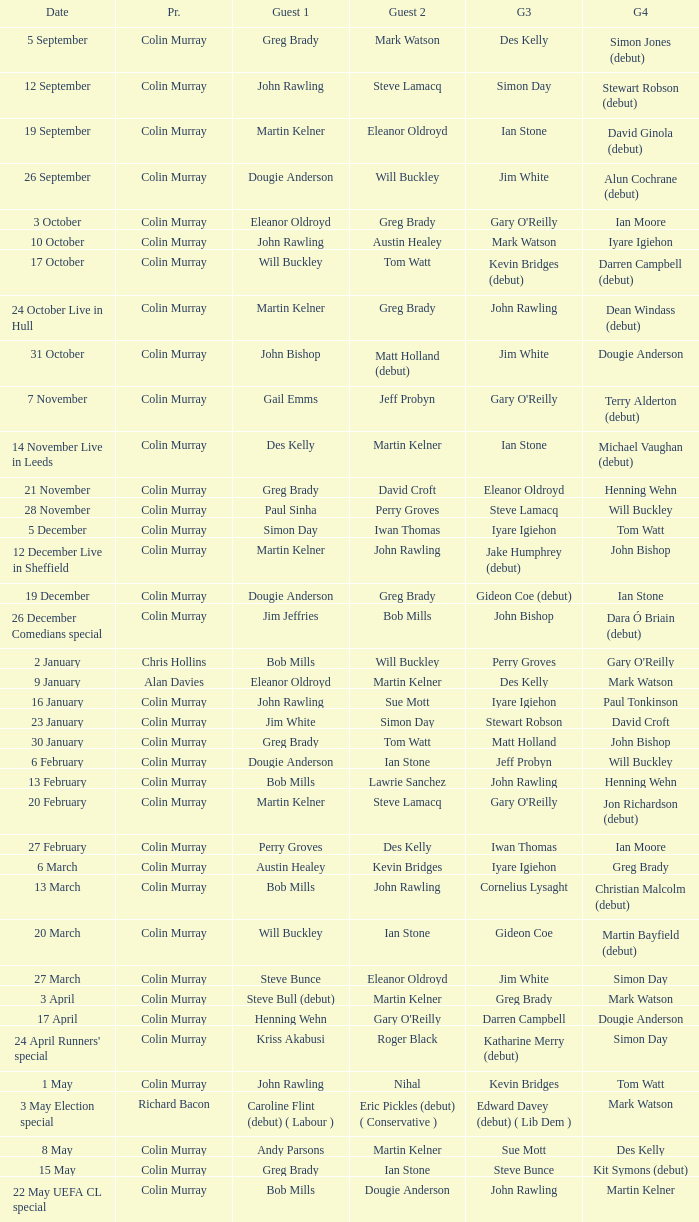How many people are guest 1 on episodes where guest 4 is Des Kelly? 1.0. 